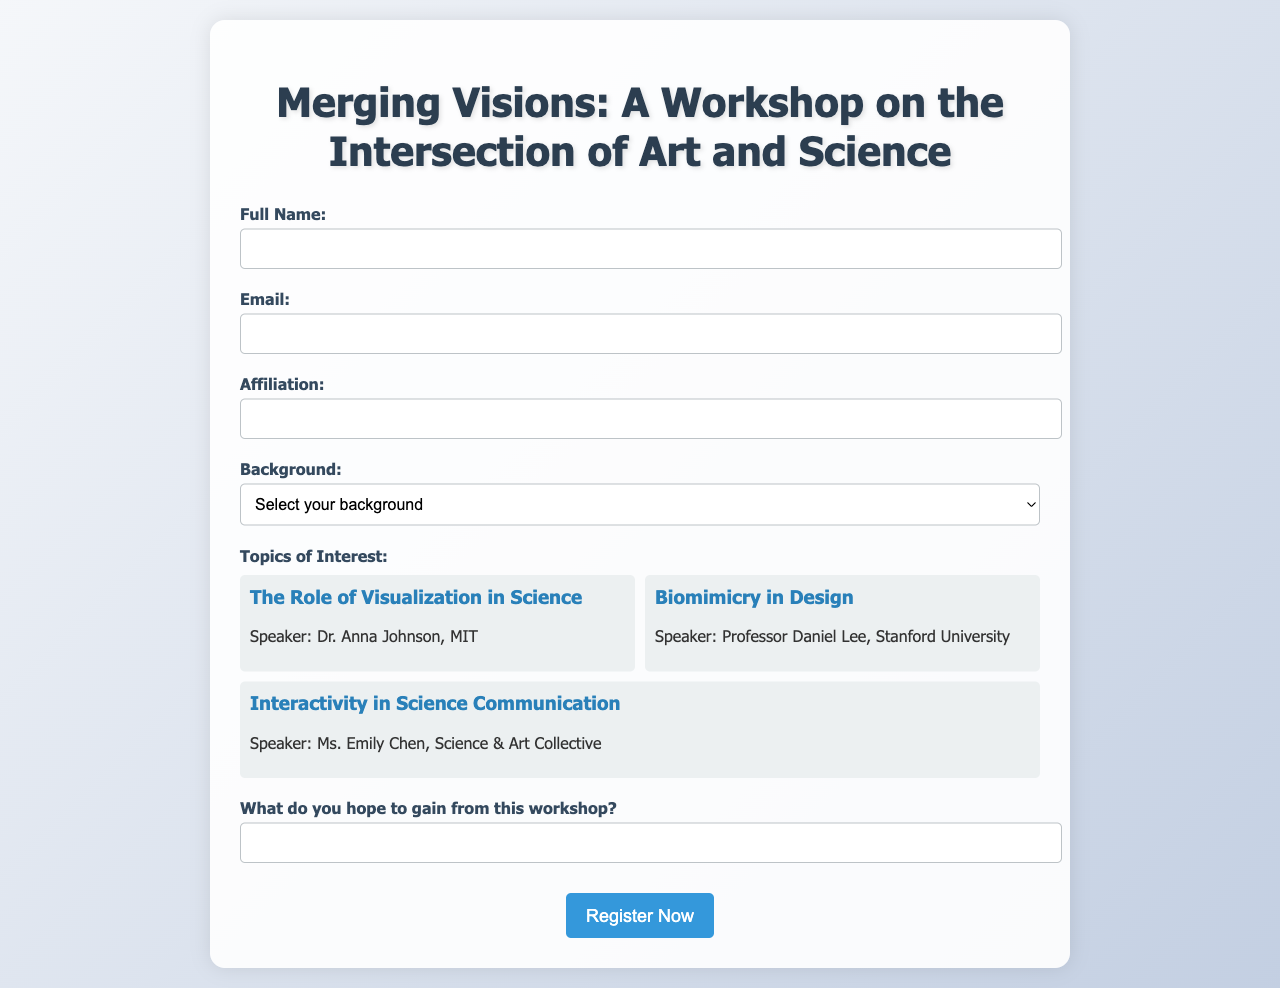What is the title of the workshop? The title of the workshop is provided at the top of the document, which is "Merging Visions: A Workshop on the Intersection of Art and Science."
Answer: Merging Visions: A Workshop on the Intersection of Art and Science Who is the speaker for "The Role of Visualization in Science"? The speaker's name for this topic is mentioned within the topic card for "The Role of Visualization in Science" in the document.
Answer: Dr. Anna Johnson What is the maximum width of the container? The maximum width of the container is specified in the style section of the document, which states it should be 800 pixels.
Answer: 800px What affiliation must the participants provide? The document requires participants to give their affiliation as part of the registration form.
Answer: Affiliation Which topic of interest has Ms. Emily Chen as a speaker? This information is found under the topics section where Ms. Emily Chen is mentioned in connection with her specific topic.
Answer: Interactivity in Science Communication What type of background is not listed in the background options? The background options provided in the document include several categories; finding the missing option would yield the answer.
Answer: None What color is the submit button when hovered over? The document specifies the color change of the submit button when hovered over, indicating what it turns to during that action.
Answer: #2980b9 What is the expected action after filling out the form? The action expected after form completion is indicated by the button at the end of the document, which suggests what happens next.
Answer: Register Now 